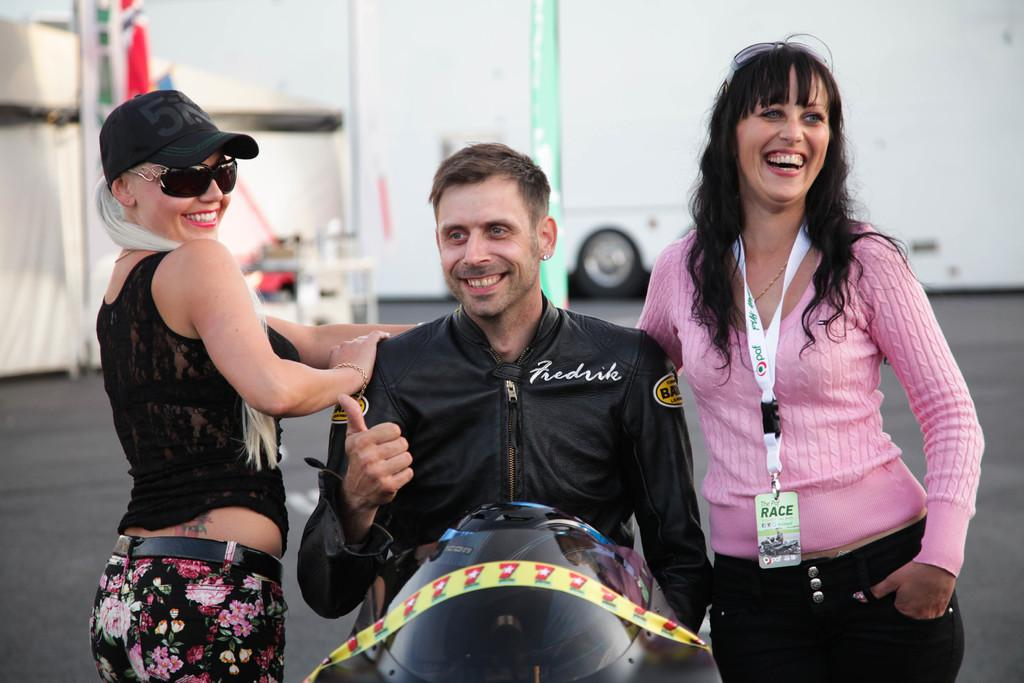What is the man in the image doing? The man is sitting on a motor vehicle in the image. Who else is present in the image? There is a woman standing on the floor in the image. What can be seen in the background of the image? There is a tent and another motor vehicle in the background of the image. What type of curve can be seen on the man's face in the image? There is no curve visible on the man's face in the image. What scale is used to measure the size of the tent in the image? The image does not provide a scale for measuring the size of the tent. 